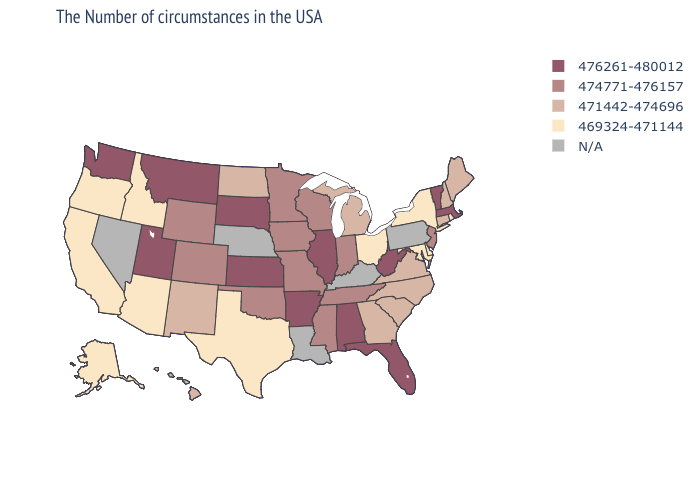Which states have the highest value in the USA?
Answer briefly. Massachusetts, Vermont, West Virginia, Florida, Alabama, Illinois, Arkansas, Kansas, South Dakota, Utah, Montana, Washington. Does Vermont have the lowest value in the USA?
Short answer required. No. What is the highest value in the West ?
Keep it brief. 476261-480012. What is the value of South Carolina?
Keep it brief. 471442-474696. What is the value of New York?
Give a very brief answer. 469324-471144. Among the states that border Missouri , does Illinois have the highest value?
Keep it brief. Yes. What is the lowest value in the USA?
Short answer required. 469324-471144. Name the states that have a value in the range 476261-480012?
Be succinct. Massachusetts, Vermont, West Virginia, Florida, Alabama, Illinois, Arkansas, Kansas, South Dakota, Utah, Montana, Washington. Which states hav the highest value in the South?
Answer briefly. West Virginia, Florida, Alabama, Arkansas. What is the value of Maryland?
Write a very short answer. 469324-471144. Does the map have missing data?
Concise answer only. Yes. Among the states that border Massachusetts , does Connecticut have the highest value?
Keep it brief. No. Does the map have missing data?
Give a very brief answer. Yes. Name the states that have a value in the range 474771-476157?
Concise answer only. New Jersey, Indiana, Tennessee, Wisconsin, Mississippi, Missouri, Minnesota, Iowa, Oklahoma, Wyoming, Colorado. 